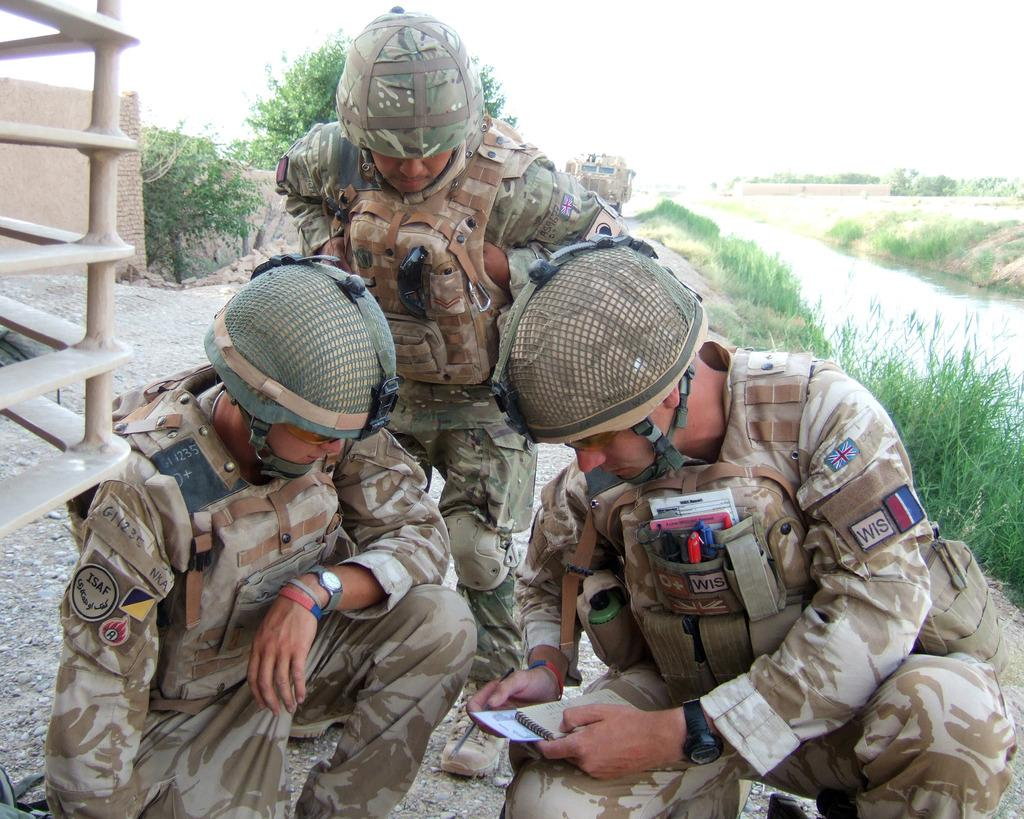What is happening on the road in the image? There are persons on the road in the image. What can be seen in the background of the image? There is a wall, trees, a vehicle, plants, grass, and water visible in the background of the image. What type of cheese is being used to construct the wall in the image? There is no cheese present in the image; the wall is not made of cheese. How many wheels are visible on the persons in the image? The persons in the image do not have wheels; they are not vehicles. 